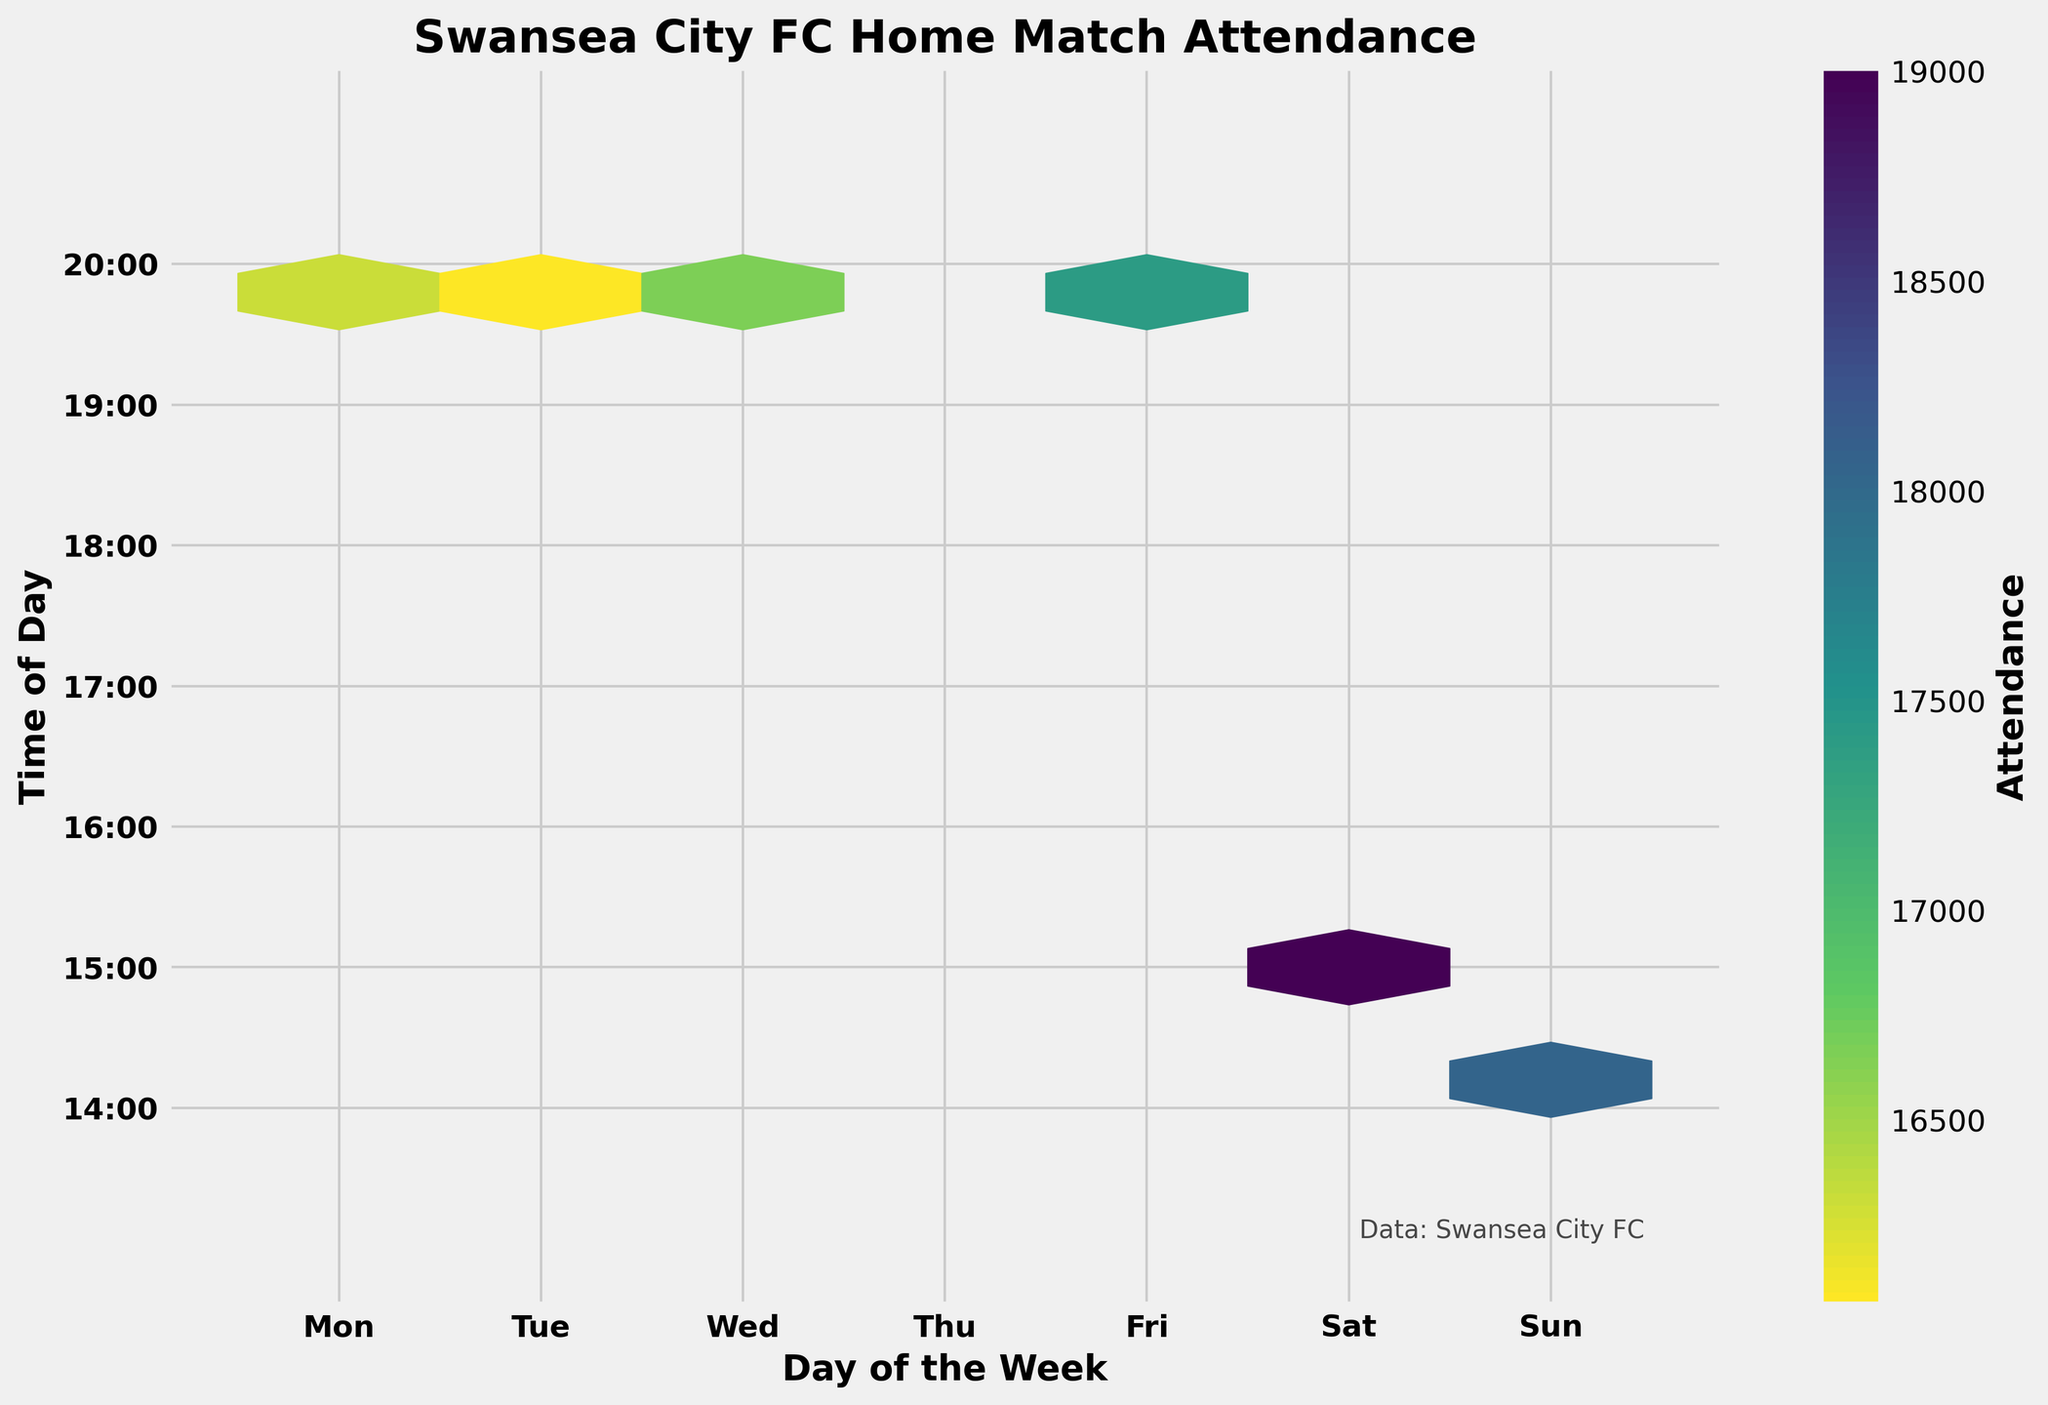What is the title of the hexbin plot? The title is located prominently at the top of the figure, stating the overall subject of the plot.
Answer: Swansea City FC Home Match Attendance What is the range of the x-axis values in the plot? The x-axis represents the days of the week and ranges from Monday to Sunday, labeled as 'Mon' to 'Sun'.
Answer: Monday to Sunday What does the color bar to the right of the plot represent? The color bar indicates the attendance levels, with different shades representing varying attendance numbers.
Answer: Attendance Which day has the highest concentration of matches in the afternoon? By looking at the color density, the highest concentration of afternoon matches is indicated by denser hexagons around 'Saturday' on the x-axis and '15:00' on the y-axis.
Answer: Saturday Between 19:00 and 21:00, which day shows the highest attendance levels? By observing the color density between 19:00 and 21:00 across all days, 'Tuesday' and 'Wednesday' seem to show high attendance, but Tuesday has slightly denser colors overall.
Answer: Tuesday On which day and time are the lowest attendance matches observed? By identifying the lightest color hexagons, which reflect lower attendance, these are mostly around 'Monday' at '20:00'.
Answer: Monday How does the attendance on Saturdays at 15:00 compare to that on Tuesdays at 19:45? The hexagonal color density on Saturdays at 15:00 is much more intense, indicating higher attendance compared to Tuesdays at 19:45.
Answer: Higher on Saturdays at 15:00 Are there any home matches played on Thursday as shown in the plot? Checking the x-axis, Thursday is labeled but has no corresponding hexagonal color, indicating no matches.
Answer: No What is the primary time of day when Sunday matches occur? Noting the hexagon concentrations on 'Sunday' reveals they are mostly around '14:00'.
Answer: 14:00 